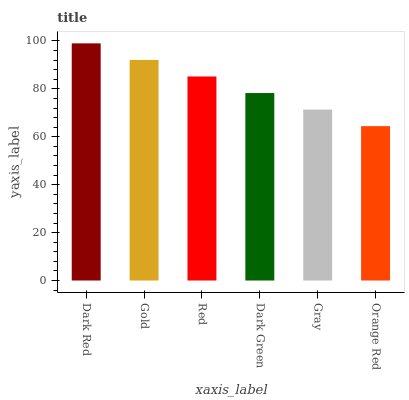Is Orange Red the minimum?
Answer yes or no. Yes. Is Dark Red the maximum?
Answer yes or no. Yes. Is Gold the minimum?
Answer yes or no. No. Is Gold the maximum?
Answer yes or no. No. Is Dark Red greater than Gold?
Answer yes or no. Yes. Is Gold less than Dark Red?
Answer yes or no. Yes. Is Gold greater than Dark Red?
Answer yes or no. No. Is Dark Red less than Gold?
Answer yes or no. No. Is Red the high median?
Answer yes or no. Yes. Is Dark Green the low median?
Answer yes or no. Yes. Is Gold the high median?
Answer yes or no. No. Is Gold the low median?
Answer yes or no. No. 